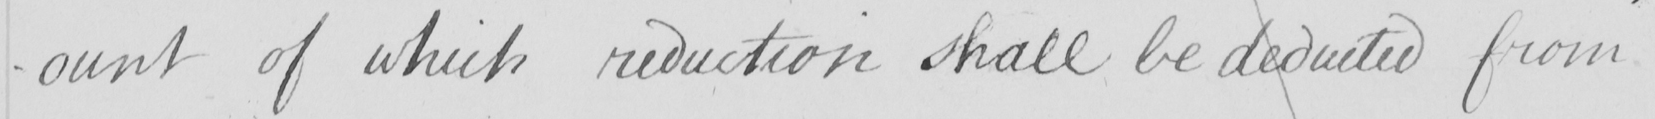What is written in this line of handwriting? -ount of which reduction shall be deducted from 